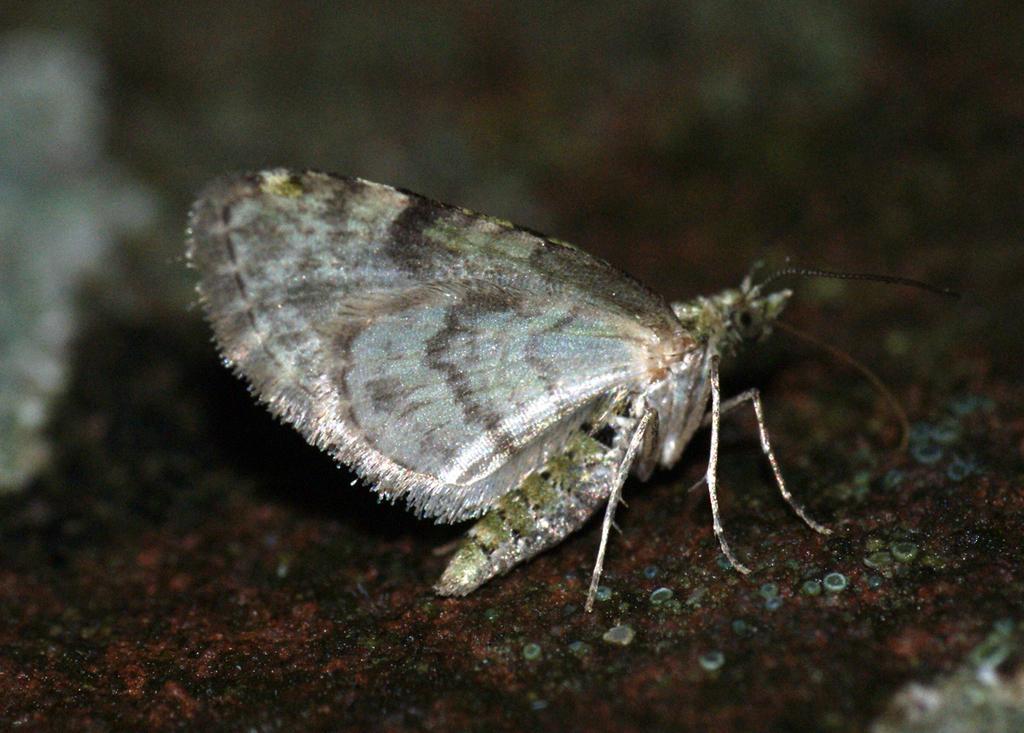Can you describe this image briefly? In this image we can see an insect on a platform. In the background the image is blur. 